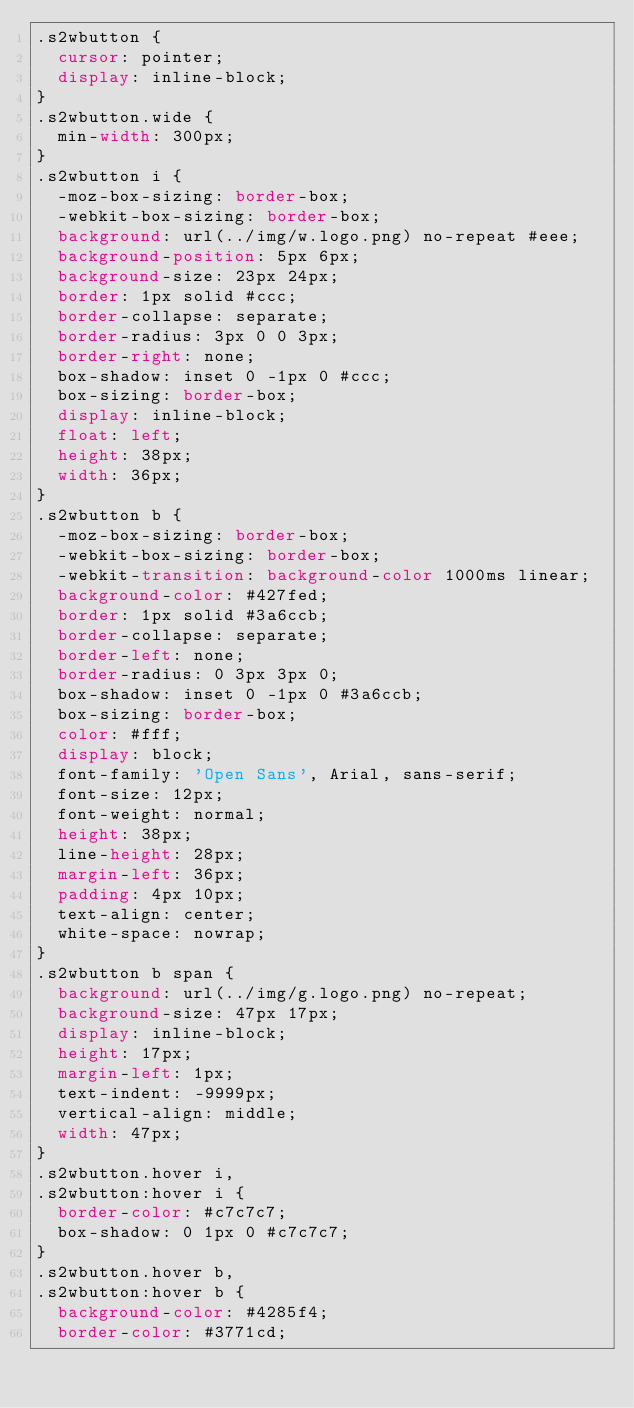<code> <loc_0><loc_0><loc_500><loc_500><_CSS_>.s2wbutton {
  cursor: pointer;
  display: inline-block;
}
.s2wbutton.wide {
  min-width: 300px;
}
.s2wbutton i {
  -moz-box-sizing: border-box;
  -webkit-box-sizing: border-box;
  background: url(../img/w.logo.png) no-repeat #eee;
  background-position: 5px 6px;
  background-size: 23px 24px;
  border: 1px solid #ccc;
  border-collapse: separate;
  border-radius: 3px 0 0 3px;
  border-right: none;
  box-shadow: inset 0 -1px 0 #ccc;
  box-sizing: border-box;
  display: inline-block;
  float: left;
  height: 38px;
  width: 36px;
}
.s2wbutton b {
  -moz-box-sizing: border-box;
  -webkit-box-sizing: border-box;
  -webkit-transition: background-color 1000ms linear;
  background-color: #427fed;
  border: 1px solid #3a6ccb;
  border-collapse: separate;
  border-left: none;
  border-radius: 0 3px 3px 0;
  box-shadow: inset 0 -1px 0 #3a6ccb;
  box-sizing: border-box;
  color: #fff;
  display: block;
  font-family: 'Open Sans', Arial, sans-serif;
  font-size: 12px;
  font-weight: normal;
  height: 38px;
  line-height: 28px;
  margin-left: 36px;
  padding: 4px 10px;
  text-align: center;
  white-space: nowrap;
}
.s2wbutton b span {
  background: url(../img/g.logo.png) no-repeat;
  background-size: 47px 17px;
  display: inline-block;
  height: 17px;
  margin-left: 1px;
  text-indent: -9999px;
  vertical-align: middle;
  width: 47px;
}
.s2wbutton.hover i,
.s2wbutton:hover i {
  border-color: #c7c7c7;
  box-shadow: 0 1px 0 #c7c7c7;
}
.s2wbutton.hover b,
.s2wbutton:hover b {
  background-color: #4285f4;
  border-color: #3771cd;</code> 